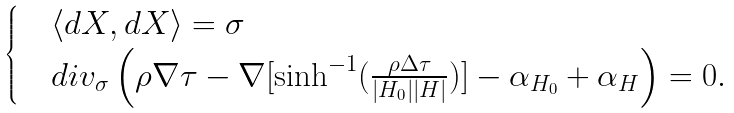<formula> <loc_0><loc_0><loc_500><loc_500>\begin{cases} & \langle d X , d X \rangle = \sigma \\ & d i v _ { \sigma } \left ( \rho \nabla \tau - \nabla [ \sinh ^ { - 1 } ( \frac { \rho \Delta \tau } { | H _ { 0 } | | H | } ) ] - \alpha _ { H _ { 0 } } + \alpha _ { H } \right ) = 0 . \end{cases}</formula> 